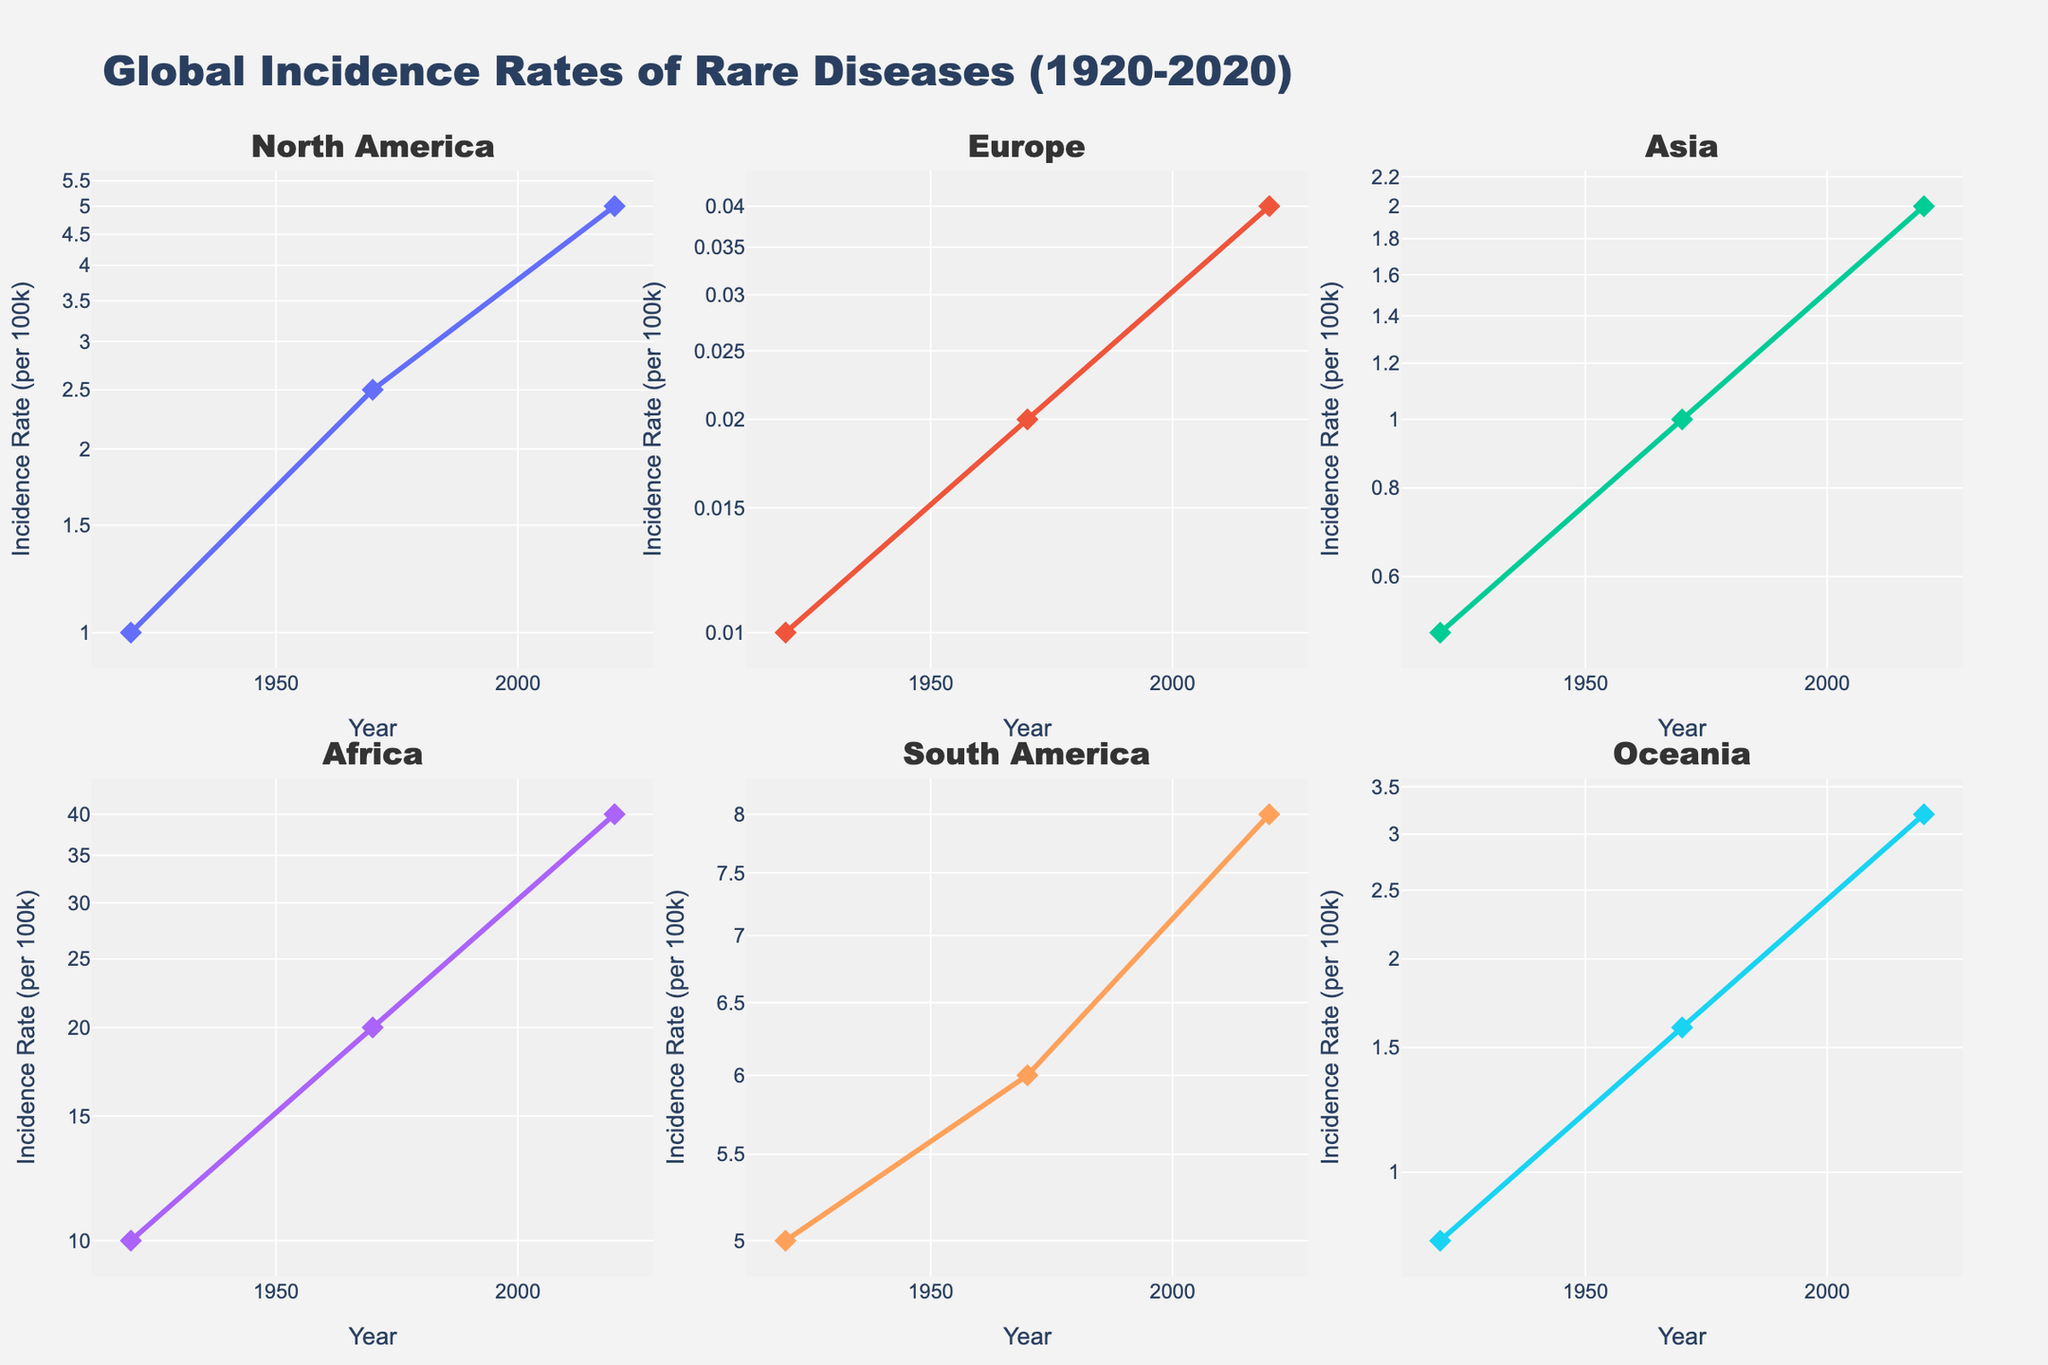What is the title of the figure? The title of the figure is located at the top center of the plot and it labels the overall content of the figure. According to the figure's settings, it reads "Global Incidence Rates of Rare Diseases (1920-2020)".
Answer: Global Incidence Rates of Rare Diseases (1920-2020) How many subplots are present in the figure? Subplots are sections of the main plot dedicated to different data setups. In this case, there are visual sections separated by continent. Counting all these sections, there are 6 subplots.
Answer: 6 Which continent has the highest incidence rate for any disease in 2020? To determine this, examine each of the 2020 data points across all subplots and identify the one with the highest value. Africa has the highest rate for Sickle Cell Anemia which reaches 40.0.
Answer: Africa What is the incidence growth rate for Huntington's Disease in North America from 1920 to 2020? First, subtract the 1920 incidence rate (1.0) from the 2020 incidence rate (5.0). Therefore, the growth rate is 5.0 - 1.0 = 4.0.
Answer: 4.0 Which continents have diseases with incidence rates lower than 1.0 in 1920? Check the 1920 incidence data points in each subplot. The continents with rates below 1.0 are Europe for Progeria (0.01) and Asia for Cystic Fibrosis (0.5), and Oceania for Phenylketonuria (PKU) (0.8).
Answer: Europe, Asia, Oceania Compare the incidence rate trends for Cystic Fibrosis in Asia and Sickle Cell Anemia in Africa. Which one increases more dramatically? Review the log scale trends from 1920 to 2020 for both diseases. Sickle Cell Anemia in Africa rises from 10.0 to 40.0, whereas Cystic Fibrosis in Asia rises from 0.5 to 2.0. A log scale increase reflects exponential growth, and Sickle Cell Anemia’s increment of 4 times is larger than the 4 times increment of Cystic Fibrosis when considering their starting values.
Answer: Sickle Cell Anemia What pattern do you observe in the incidence rates of rare diseases in continents from 1920 to 2020? Observe each subplot's trend on the log scale. Generally, all diseases in each continent show a rising trend, indicating an overall increase in reported incidence rates of rare diseases over the century.
Answer: Increasing trend Which continent shows an incidence rate for a disease closest to 1.0 in 1970? Find the 1970 data points across subplots. The closest to 1.0 is Cystic Fibrosis in Asia with an incidence rate of exactly 1.0.
Answer: Asia By how many times did the incidence rate for Phenylketonuria (PKU) in Oceania grow from 1920 to 2020? Use the log scale property to quantify growth. The rate in 1920 was 0.8, and in 2020 it’s 3.2. Divide the 2020 rate by the 1920 rate: 3.2 / 0.8 = 4.
Answer: 4 